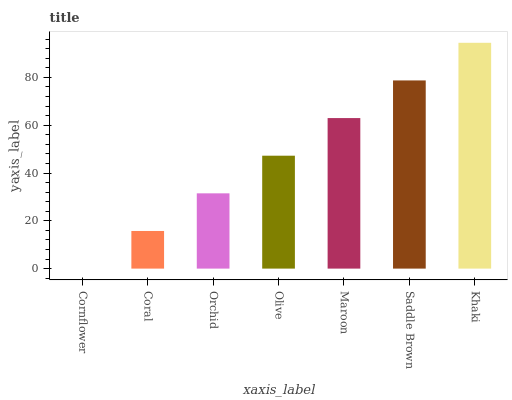Is Cornflower the minimum?
Answer yes or no. Yes. Is Khaki the maximum?
Answer yes or no. Yes. Is Coral the minimum?
Answer yes or no. No. Is Coral the maximum?
Answer yes or no. No. Is Coral greater than Cornflower?
Answer yes or no. Yes. Is Cornflower less than Coral?
Answer yes or no. Yes. Is Cornflower greater than Coral?
Answer yes or no. No. Is Coral less than Cornflower?
Answer yes or no. No. Is Olive the high median?
Answer yes or no. Yes. Is Olive the low median?
Answer yes or no. Yes. Is Cornflower the high median?
Answer yes or no. No. Is Khaki the low median?
Answer yes or no. No. 